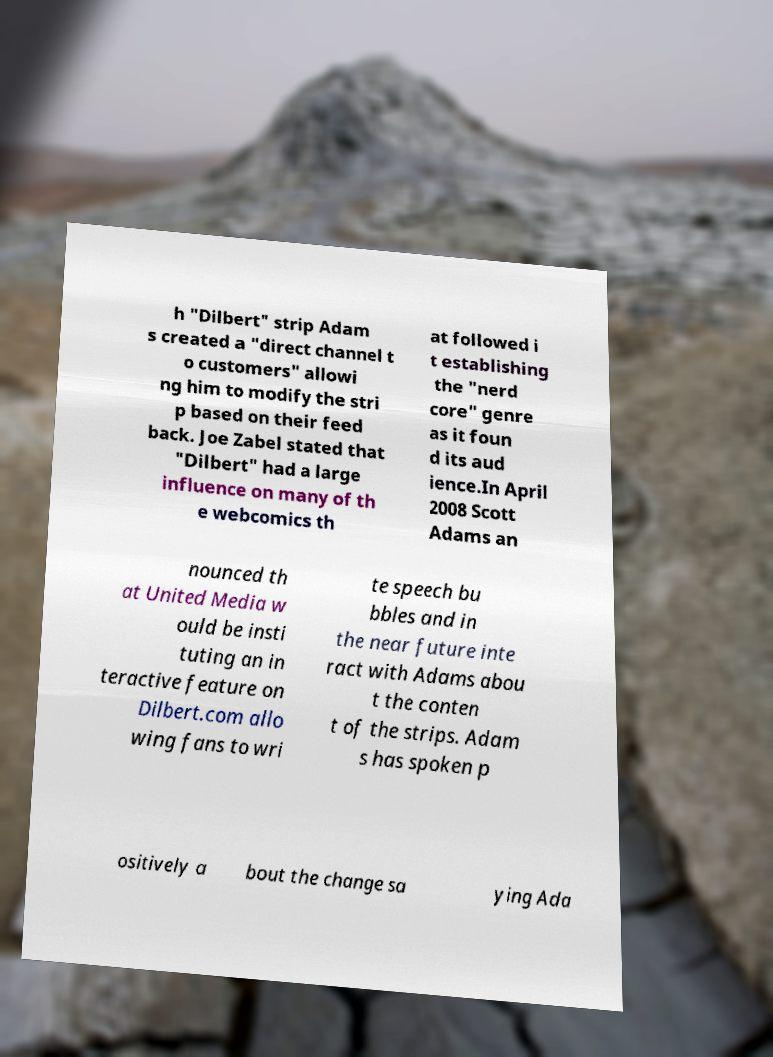I need the written content from this picture converted into text. Can you do that? h "Dilbert" strip Adam s created a "direct channel t o customers" allowi ng him to modify the stri p based on their feed back. Joe Zabel stated that "Dilbert" had a large influence on many of th e webcomics th at followed i t establishing the "nerd core" genre as it foun d its aud ience.In April 2008 Scott Adams an nounced th at United Media w ould be insti tuting an in teractive feature on Dilbert.com allo wing fans to wri te speech bu bbles and in the near future inte ract with Adams abou t the conten t of the strips. Adam s has spoken p ositively a bout the change sa ying Ada 